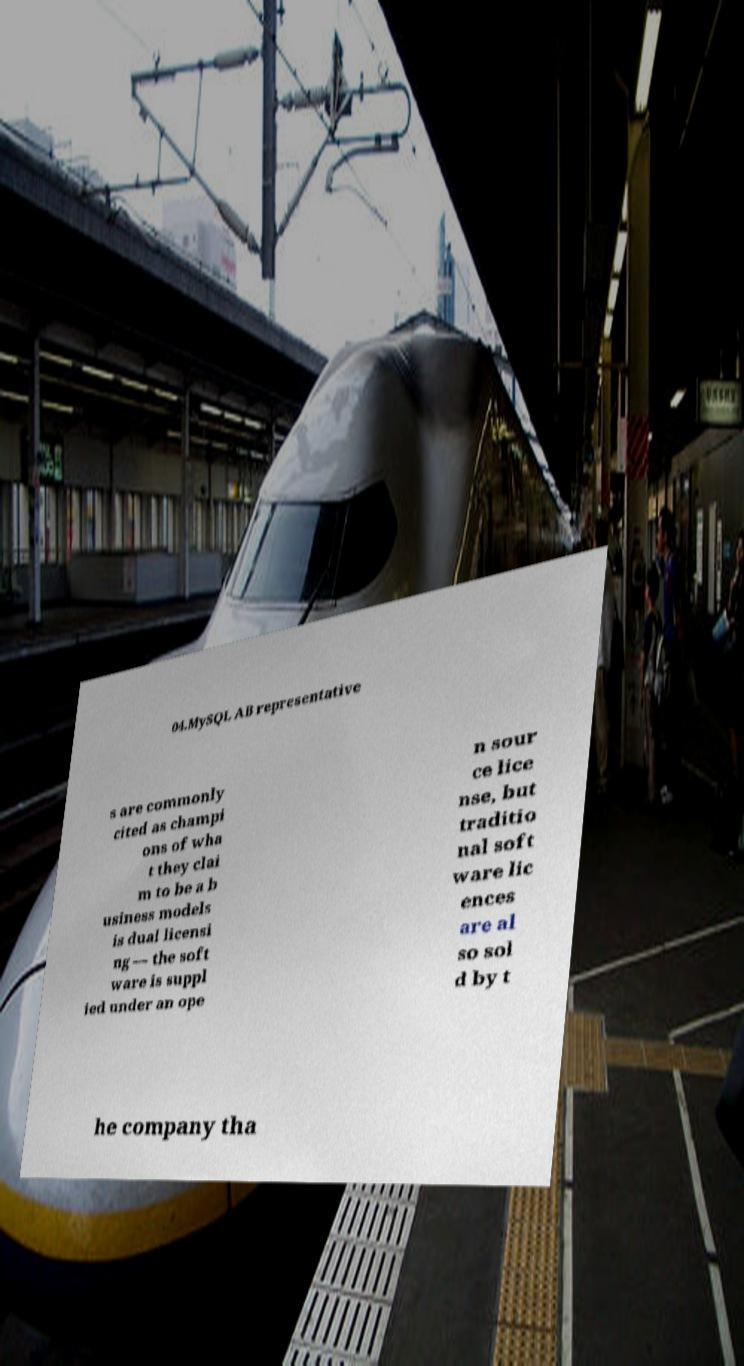Please identify and transcribe the text found in this image. 04.MySQL AB representative s are commonly cited as champi ons of wha t they clai m to be a b usiness models is dual licensi ng — the soft ware is suppl ied under an ope n sour ce lice nse, but traditio nal soft ware lic ences are al so sol d by t he company tha 